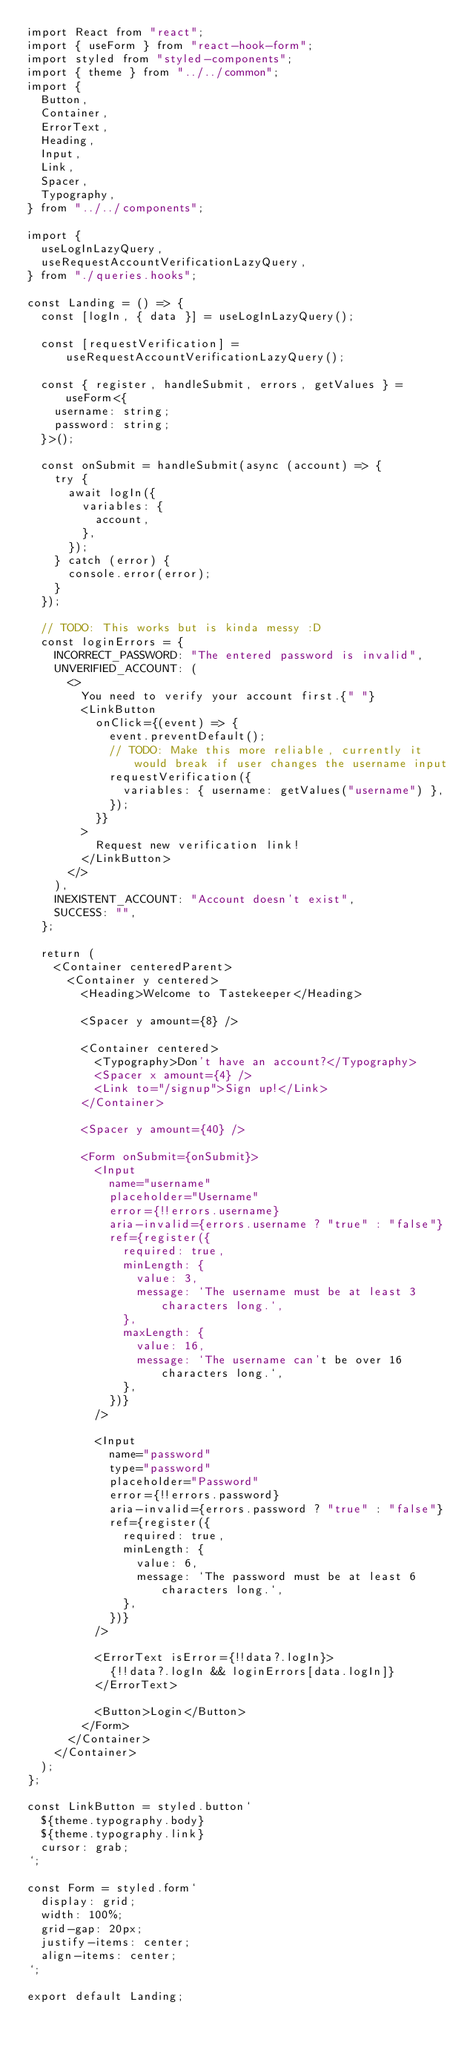Convert code to text. <code><loc_0><loc_0><loc_500><loc_500><_TypeScript_>import React from "react";
import { useForm } from "react-hook-form";
import styled from "styled-components";
import { theme } from "../../common";
import {
  Button,
  Container,
  ErrorText,
  Heading,
  Input,
  Link,
  Spacer,
  Typography,
} from "../../components";

import {
  useLogInLazyQuery,
  useRequestAccountVerificationLazyQuery,
} from "./queries.hooks";

const Landing = () => {
  const [logIn, { data }] = useLogInLazyQuery();

  const [requestVerification] = useRequestAccountVerificationLazyQuery();

  const { register, handleSubmit, errors, getValues } = useForm<{
    username: string;
    password: string;
  }>();

  const onSubmit = handleSubmit(async (account) => {
    try {
      await logIn({
        variables: {
          account,
        },
      });
    } catch (error) {
      console.error(error);
    }
  });

  // TODO: This works but is kinda messy :D
  const loginErrors = {
    INCORRECT_PASSWORD: "The entered password is invalid",
    UNVERIFIED_ACCOUNT: (
      <>
        You need to verify your account first.{" "}
        <LinkButton
          onClick={(event) => {
            event.preventDefault();
            // TODO: Make this more reliable, currently it would break if user changes the username input
            requestVerification({
              variables: { username: getValues("username") },
            });
          }}
        >
          Request new verification link!
        </LinkButton>
      </>
    ),
    INEXISTENT_ACCOUNT: "Account doesn't exist",
    SUCCESS: "",
  };

  return (
    <Container centeredParent>
      <Container y centered>
        <Heading>Welcome to Tastekeeper</Heading>

        <Spacer y amount={8} />

        <Container centered>
          <Typography>Don't have an account?</Typography>
          <Spacer x amount={4} />
          <Link to="/signup">Sign up!</Link>
        </Container>

        <Spacer y amount={40} />

        <Form onSubmit={onSubmit}>
          <Input
            name="username"
            placeholder="Username"
            error={!!errors.username}
            aria-invalid={errors.username ? "true" : "false"}
            ref={register({
              required: true,
              minLength: {
                value: 3,
                message: `The username must be at least 3 characters long.`,
              },
              maxLength: {
                value: 16,
                message: `The username can't be over 16 characters long.`,
              },
            })}
          />

          <Input
            name="password"
            type="password"
            placeholder="Password"
            error={!!errors.password}
            aria-invalid={errors.password ? "true" : "false"}
            ref={register({
              required: true,
              minLength: {
                value: 6,
                message: `The password must be at least 6 characters long.`,
              },
            })}
          />

          <ErrorText isError={!!data?.logIn}>
            {!!data?.logIn && loginErrors[data.logIn]}
          </ErrorText>

          <Button>Login</Button>
        </Form>
      </Container>
    </Container>
  );
};

const LinkButton = styled.button`
  ${theme.typography.body}
  ${theme.typography.link}
  cursor: grab;
`;

const Form = styled.form`
  display: grid;
  width: 100%;
  grid-gap: 20px;
  justify-items: center;
  align-items: center;
`;

export default Landing;
</code> 